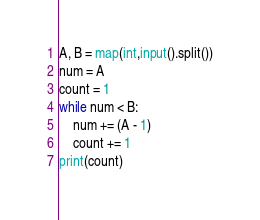Convert code to text. <code><loc_0><loc_0><loc_500><loc_500><_Python_>A, B = map(int,input().split())
num = A
count = 1
while num < B:
    num += (A - 1)
    count += 1
print(count)</code> 